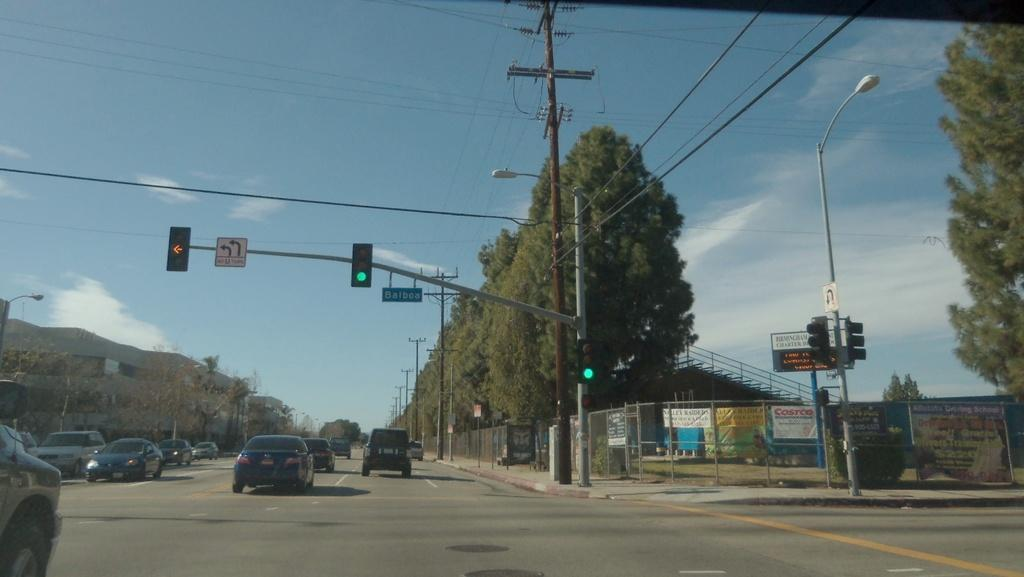<image>
Present a compact description of the photo's key features. Cars on the road coming the lights with a sign to turn left. 